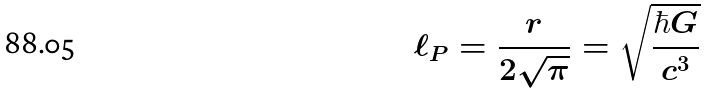<formula> <loc_0><loc_0><loc_500><loc_500>\ell _ { P } = { \frac { r } { 2 { \sqrt { \pi } } } } = { \sqrt { \frac { \hbar { G } } { c ^ { 3 } } } }</formula> 